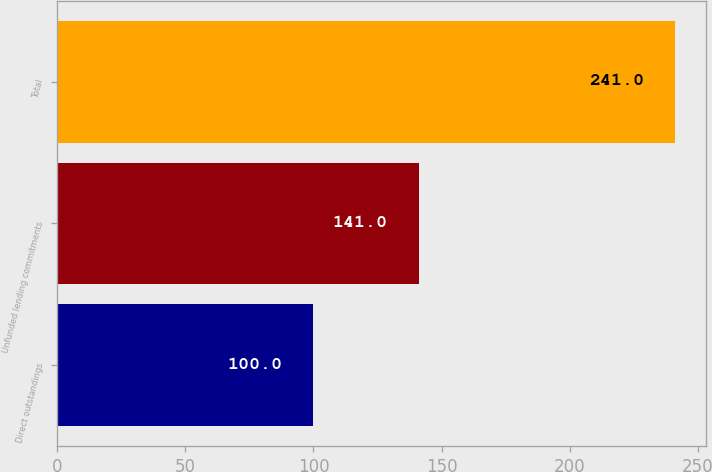<chart> <loc_0><loc_0><loc_500><loc_500><bar_chart><fcel>Direct outstandings<fcel>Unfunded lending commitments<fcel>Total<nl><fcel>100<fcel>141<fcel>241<nl></chart> 